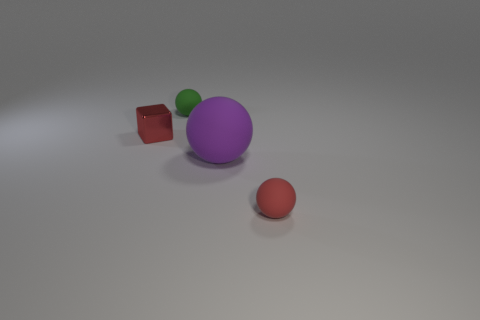Subtract all purple balls. Subtract all red blocks. How many balls are left? 2 Add 3 cylinders. How many objects exist? 7 Subtract all spheres. How many objects are left? 1 Subtract all small yellow blocks. Subtract all tiny red shiny blocks. How many objects are left? 3 Add 3 red things. How many red things are left? 5 Add 2 big rubber cylinders. How many big rubber cylinders exist? 2 Subtract 0 blue blocks. How many objects are left? 4 